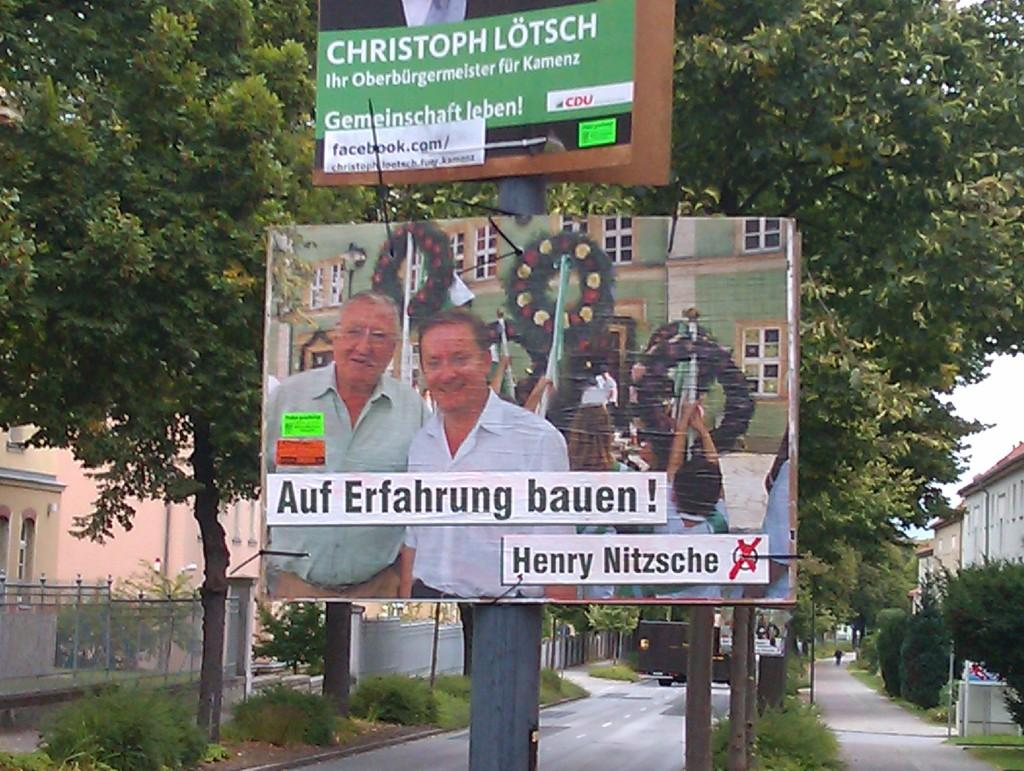<image>
Summarize the visual content of the image. An advertisement for Christoph Lotsch hangs on a pole. 